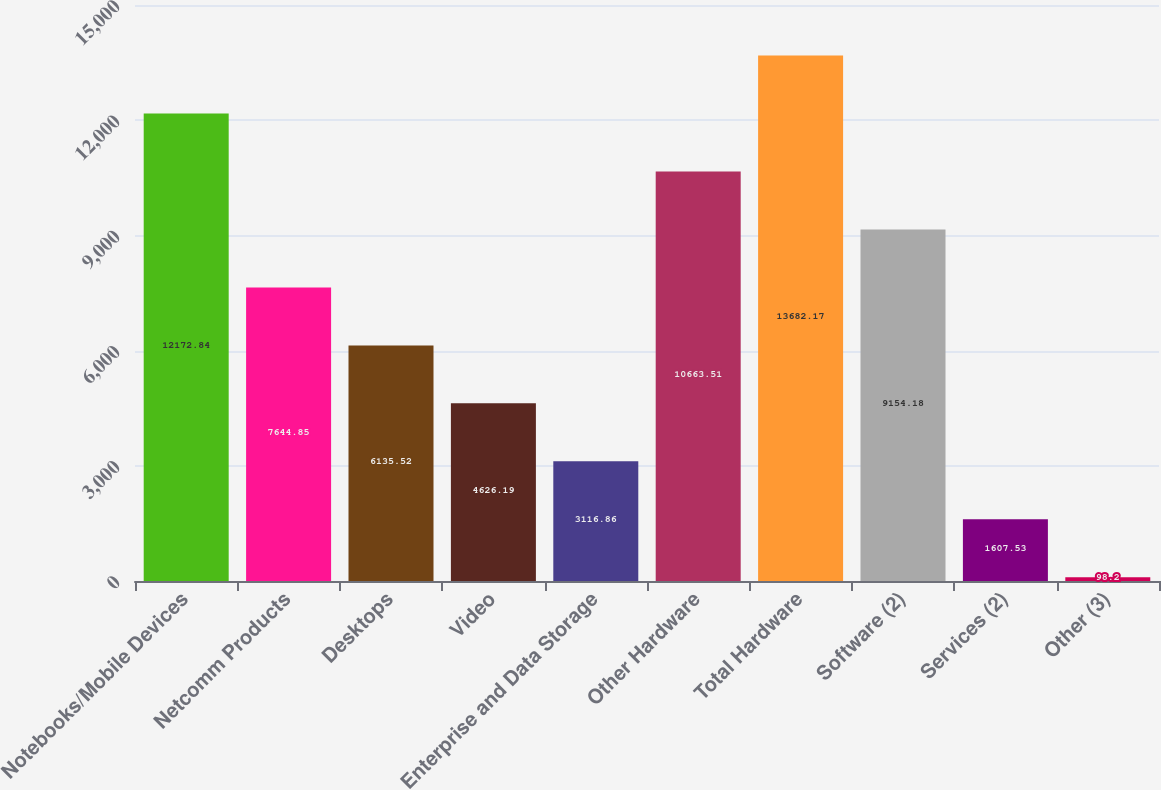<chart> <loc_0><loc_0><loc_500><loc_500><bar_chart><fcel>Notebooks/Mobile Devices<fcel>Netcomm Products<fcel>Desktops<fcel>Video<fcel>Enterprise and Data Storage<fcel>Other Hardware<fcel>Total Hardware<fcel>Software (2)<fcel>Services (2)<fcel>Other (3)<nl><fcel>12172.8<fcel>7644.85<fcel>6135.52<fcel>4626.19<fcel>3116.86<fcel>10663.5<fcel>13682.2<fcel>9154.18<fcel>1607.53<fcel>98.2<nl></chart> 